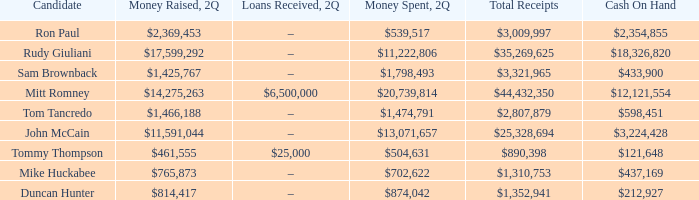Tell me the total receipts for tom tancredo $2,807,879. 